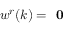Convert formula to latex. <formula><loc_0><loc_0><loc_500><loc_500>w ^ { r } ( k ) = 0</formula> 